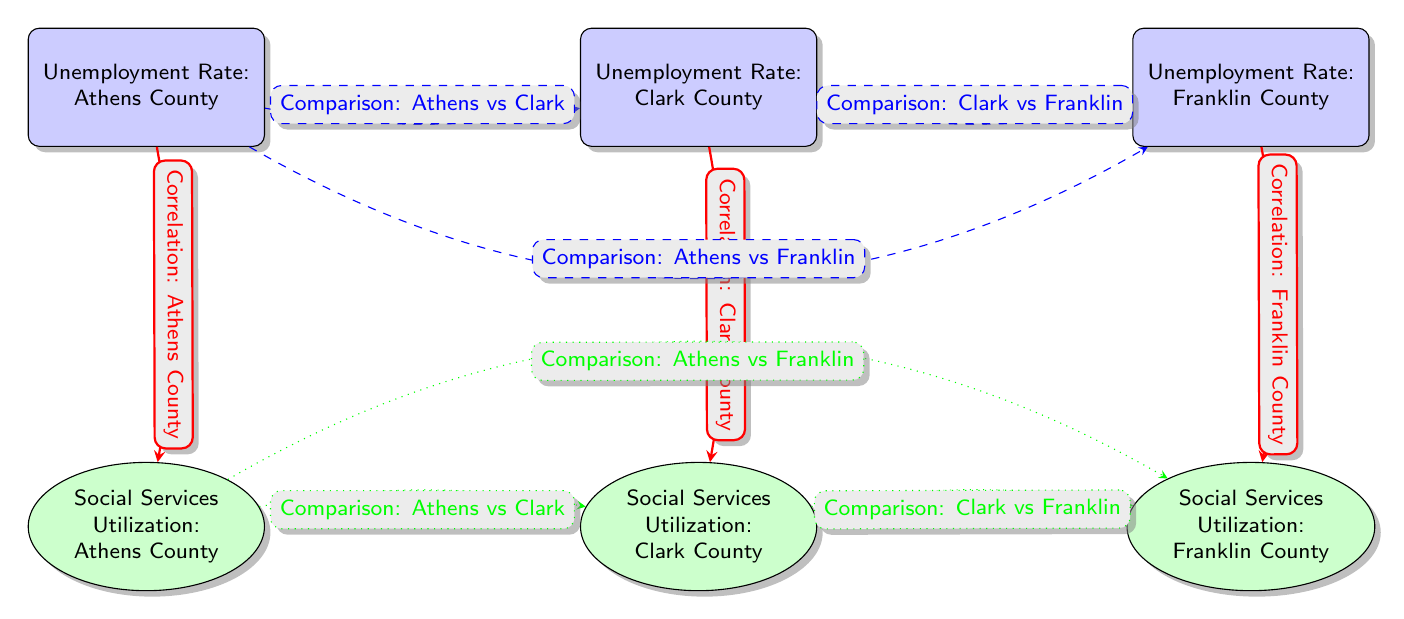What are the unemployment rates in Athens County? The unemployment rate in Athens County is displayed on the respective node labeled "Unemployment Rate: Athens County". The actual numeric value can be read directly from the node.
Answer: Athens County How many counties are shown in the diagram? By counting the unemployment rate nodes, there are three counties: Athens, Clark, and Franklin.
Answer: Three What type of correlation is indicated between Athens County and its social services utilization? The edge from the unemployment node of Athens County to its social services utilization node is thick and red, indicating that it depicts a correlation.
Answer: Correlation Which two counties are compared directly regarding their unemployment rates? The diagram shows dashed blue edges depicting comparisons; the edges between Athens County and Clark County are specifically labeled for comparison between these two.
Answer: Athens vs Clark What kind of relationship exists between social services utilization in Athens County and Clark County? A dotted green edge connects the social services utilization nodes of Athens and Clark Counties, indicating a comparison between these two metrics.
Answer: Comparison Is there any comparison between Franklin County’s unemployment rate and social services utilization in Athens County? The diagram features a dashed blue edge labeled for the unemployment rate and a dotted green edge labeled for social services utilization that connects Athens and Franklin, showing direct comparisons of both categories.
Answer: Yes What is the nature of the comparison between Clark County and Franklin County's social services utilization? The social services utilization nodes are connected by a dotted green edge labeled for comparison between Clark County and Franklin County, indicating a relationship of their social services utilization rates.
Answer: Comparison How are the connections between unemployment rates and social services utilization depicted in the diagram? The connections are illustrated with directed, colored edges that signify correlation between the unemployment rate nodes and respective social services utilization nodes for different counties.
Answer: Correlation 